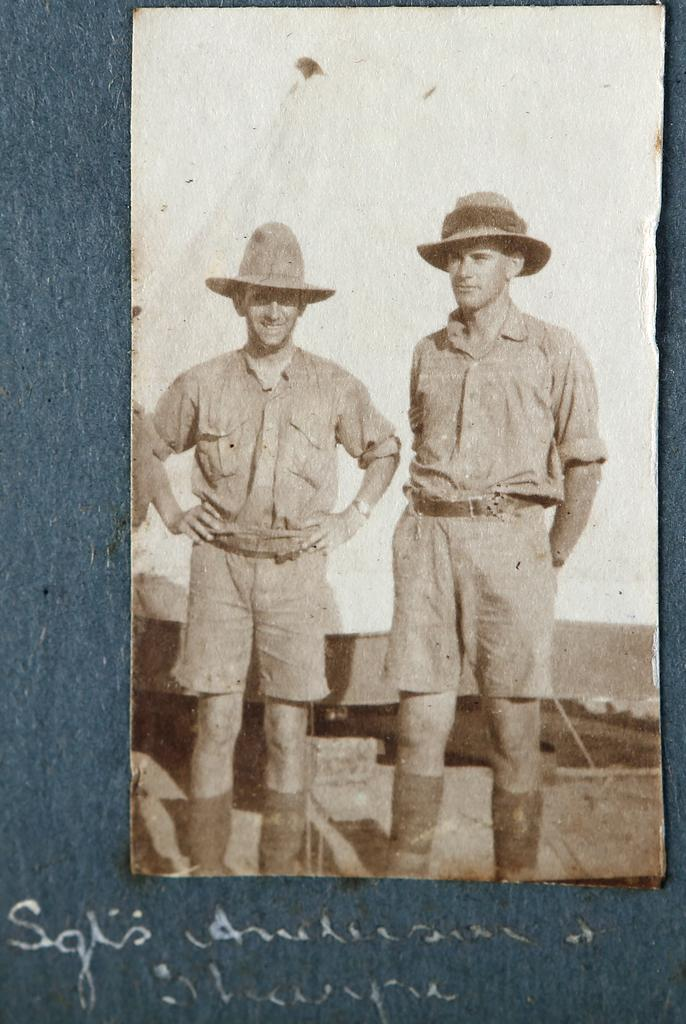What is present in the image that contains information or a message? There is a poster in the image. Can you describe what is written or displayed on the poster? There is text visible in the image. Where is the jelly stored in the image? There is no jelly present in the image. What type of laborer can be seen working in the image? There are no laborers present in the image. 